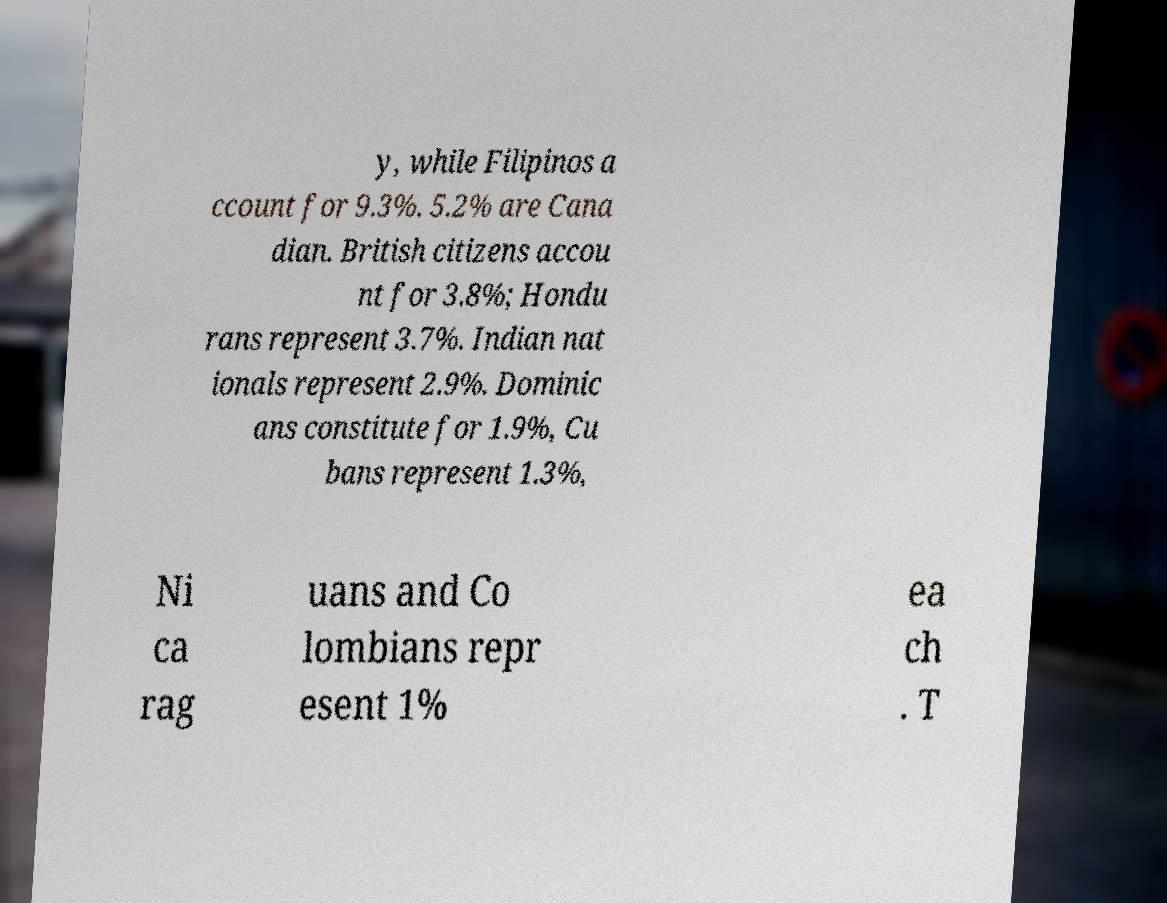Could you extract and type out the text from this image? y, while Filipinos a ccount for 9.3%. 5.2% are Cana dian. British citizens accou nt for 3.8%; Hondu rans represent 3.7%. Indian nat ionals represent 2.9%. Dominic ans constitute for 1.9%, Cu bans represent 1.3%, Ni ca rag uans and Co lombians repr esent 1% ea ch . T 